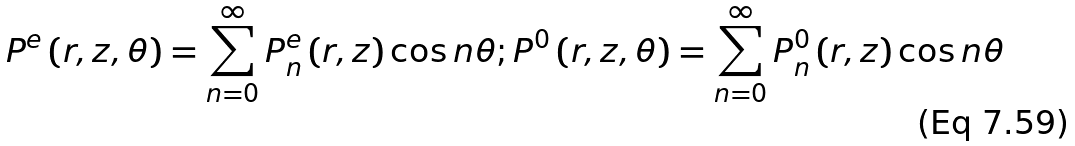<formula> <loc_0><loc_0><loc_500><loc_500>P ^ { e } \left ( r , z , \theta \right ) = \sum _ { n = 0 } ^ { \infty } P _ { n } ^ { e } \left ( r , z \right ) \cos n \theta ; P ^ { 0 } \left ( r , z , \theta \right ) = \sum _ { n = 0 } ^ { \infty } P _ { n } ^ { 0 } \left ( r , z \right ) \cos n \theta</formula> 